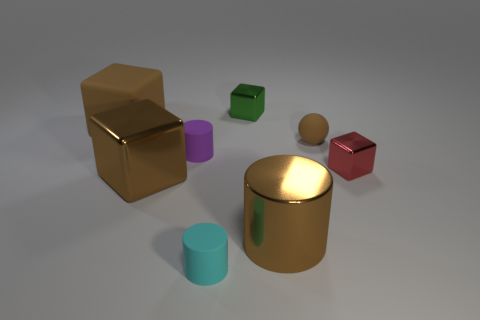Subtract all red blocks. How many blocks are left? 3 Add 1 large cyan matte blocks. How many objects exist? 9 Subtract all spheres. How many objects are left? 7 Subtract 0 cyan spheres. How many objects are left? 8 Subtract all tiny purple rubber cylinders. Subtract all shiny objects. How many objects are left? 3 Add 7 cyan things. How many cyan things are left? 8 Add 2 tiny green metallic cylinders. How many tiny green metallic cylinders exist? 2 